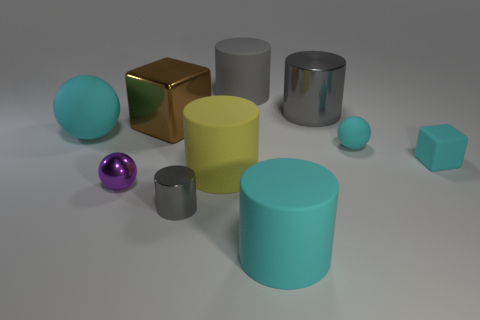The tiny cyan object that is the same material as the tiny cyan block is what shape?
Offer a terse response. Sphere. What color is the small block that is to the right of the big shiny object that is right of the gray matte object?
Provide a succinct answer. Cyan. Is the large matte ball the same color as the tiny metal ball?
Ensure brevity in your answer.  No. What is the material of the cyan sphere that is left of the large cyan thing right of the big gray rubber cylinder?
Make the answer very short. Rubber. There is a yellow object that is the same shape as the tiny gray metal object; what is it made of?
Ensure brevity in your answer.  Rubber. Is there a yellow rubber object that is behind the gray metallic thing that is in front of the shiny thing right of the yellow matte thing?
Provide a succinct answer. Yes. What number of other objects are the same color as the small metallic sphere?
Offer a terse response. 0. What number of objects are both behind the small rubber sphere and to the left of the large brown cube?
Your answer should be very brief. 1. There is a big yellow thing; what shape is it?
Ensure brevity in your answer.  Cylinder. What number of other objects are the same material as the cyan cube?
Your answer should be compact. 5. 